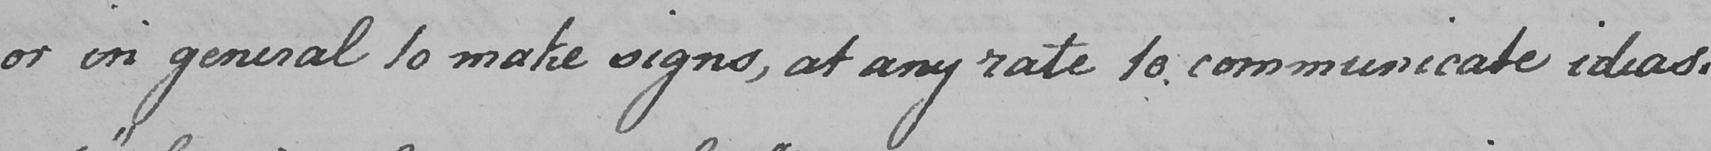Can you tell me what this handwritten text says? or in general to make signs , at any rate to communicate ideas . 